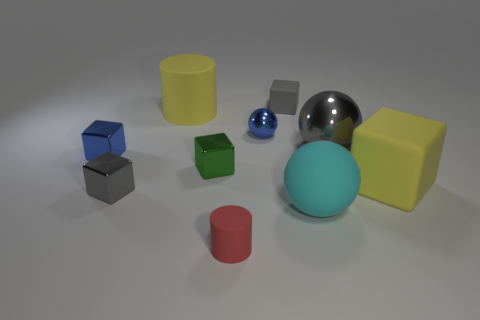Subtract all yellow blocks. How many blocks are left? 4 Subtract all blue cubes. How many cubes are left? 4 Subtract all brown blocks. Subtract all yellow cylinders. How many blocks are left? 5 Subtract all cylinders. How many objects are left? 8 Subtract all tiny purple shiny balls. Subtract all gray rubber cubes. How many objects are left? 9 Add 4 gray matte blocks. How many gray matte blocks are left? 5 Add 3 metallic objects. How many metallic objects exist? 8 Subtract 1 cyan balls. How many objects are left? 9 